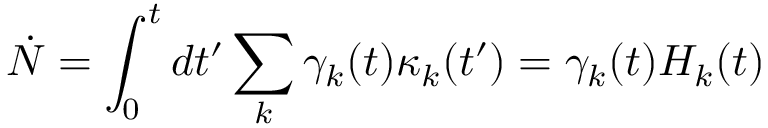Convert formula to latex. <formula><loc_0><loc_0><loc_500><loc_500>\dot { N } = \int _ { 0 } ^ { t } d t ^ { \prime } \sum _ { k } \gamma _ { k } ( t ) \kappa _ { k } ( t ^ { \prime } ) = \gamma _ { k } ( t ) H _ { k } ( t )</formula> 